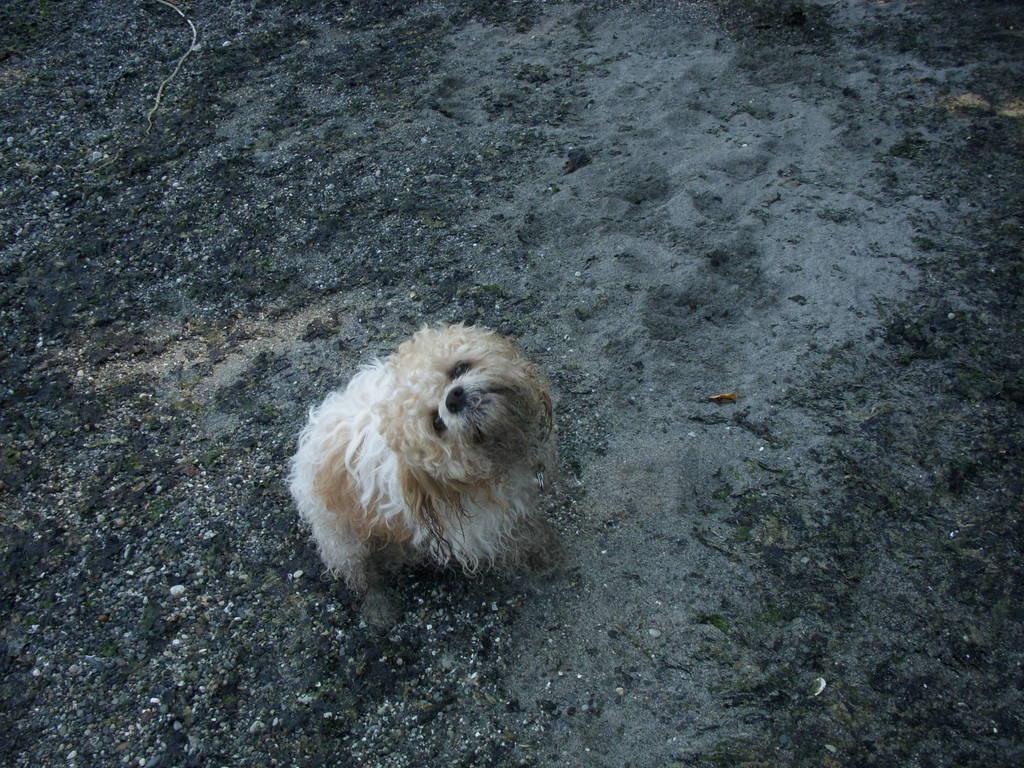Can you describe this image briefly? In this image I can see a dog on the ground. 